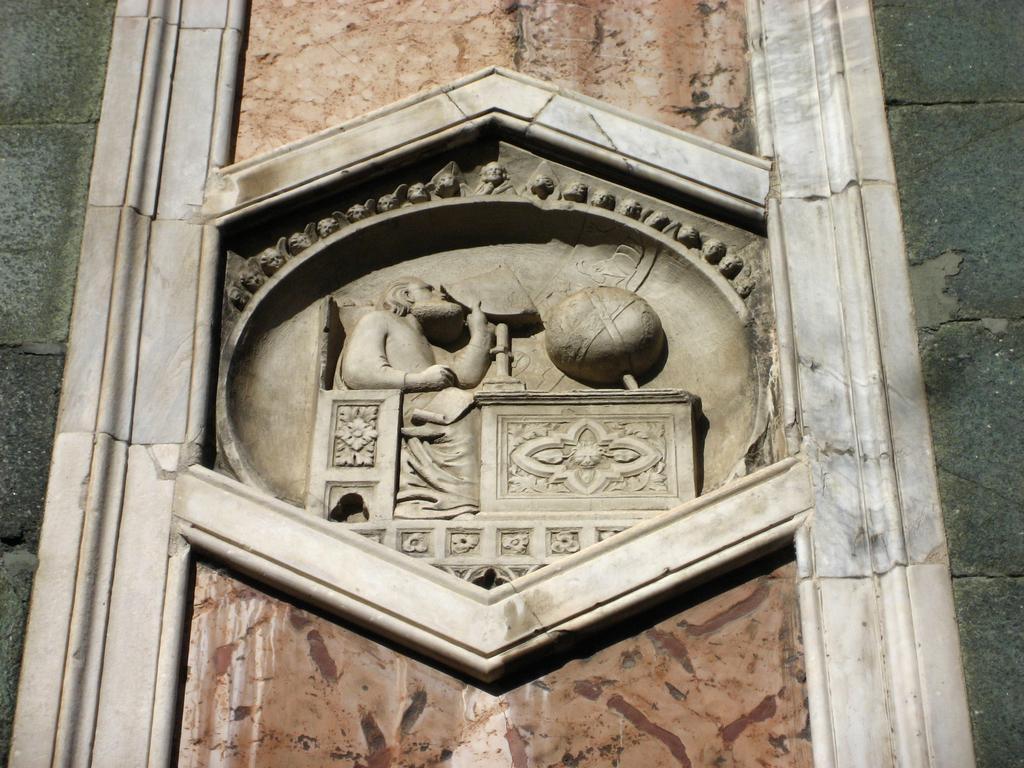In one or two sentences, can you explain what this image depicts? In this picture I can observe carving on the wall. The wall is in grey color. 